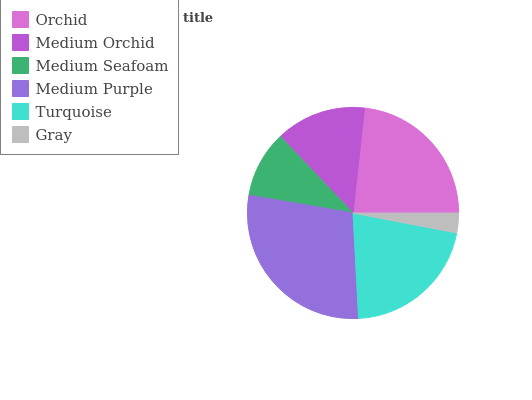Is Gray the minimum?
Answer yes or no. Yes. Is Medium Purple the maximum?
Answer yes or no. Yes. Is Medium Orchid the minimum?
Answer yes or no. No. Is Medium Orchid the maximum?
Answer yes or no. No. Is Orchid greater than Medium Orchid?
Answer yes or no. Yes. Is Medium Orchid less than Orchid?
Answer yes or no. Yes. Is Medium Orchid greater than Orchid?
Answer yes or no. No. Is Orchid less than Medium Orchid?
Answer yes or no. No. Is Turquoise the high median?
Answer yes or no. Yes. Is Medium Orchid the low median?
Answer yes or no. Yes. Is Medium Orchid the high median?
Answer yes or no. No. Is Turquoise the low median?
Answer yes or no. No. 